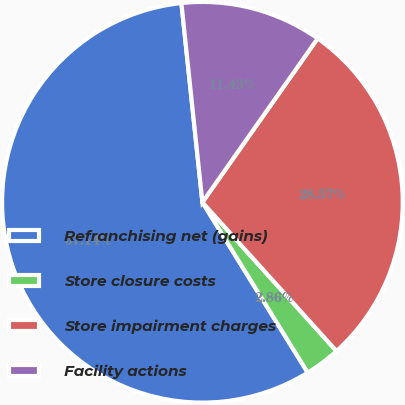Convert chart to OTSL. <chart><loc_0><loc_0><loc_500><loc_500><pie_chart><fcel>Refranchising net (gains)<fcel>Store closure costs<fcel>Store impairment charges<fcel>Facility actions<nl><fcel>57.14%<fcel>2.86%<fcel>28.57%<fcel>11.43%<nl></chart> 